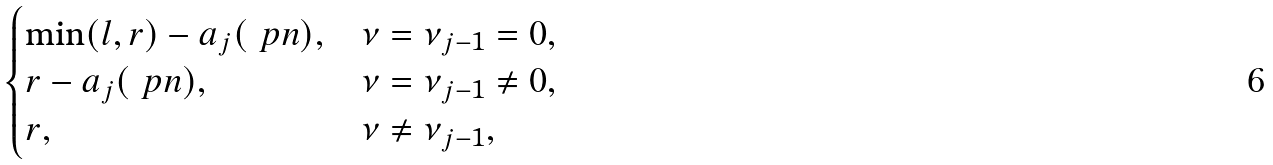Convert formula to latex. <formula><loc_0><loc_0><loc_500><loc_500>\begin{cases} \min ( l , r ) - a _ { j } ( \ p n ) , & \nu = \nu _ { j - 1 } = 0 , \\ r - a _ { j } ( \ p n ) , & \nu = \nu _ { j - 1 } \neq 0 , \\ r , & \nu \neq \nu _ { j - 1 } , \end{cases}</formula> 